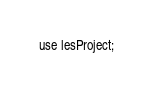Convert code to text. <code><loc_0><loc_0><loc_500><loc_500><_SQL_>use lesProject;
</code> 